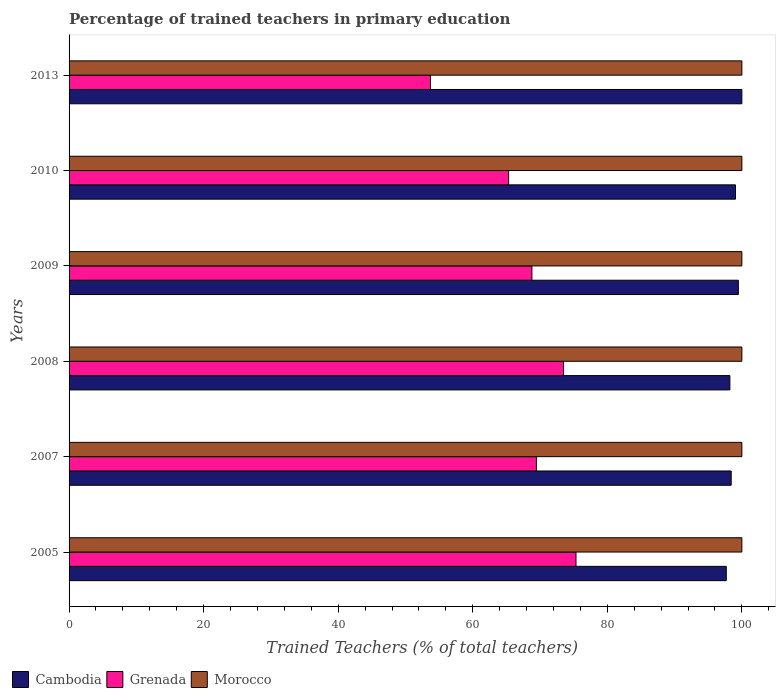Are the number of bars per tick equal to the number of legend labels?
Offer a terse response. Yes. Are the number of bars on each tick of the Y-axis equal?
Your response must be concise. Yes. How many bars are there on the 1st tick from the top?
Provide a succinct answer. 3. How many bars are there on the 4th tick from the bottom?
Your answer should be compact. 3. Across all years, what is the maximum percentage of trained teachers in Grenada?
Make the answer very short. 75.35. Across all years, what is the minimum percentage of trained teachers in Grenada?
Provide a succinct answer. 53.71. In which year was the percentage of trained teachers in Cambodia minimum?
Your response must be concise. 2005. What is the total percentage of trained teachers in Morocco in the graph?
Your answer should be compact. 600. What is the difference between the percentage of trained teachers in Grenada in 2005 and the percentage of trained teachers in Cambodia in 2007?
Give a very brief answer. -23.07. What is the average percentage of trained teachers in Cambodia per year?
Your answer should be compact. 98.81. In how many years, is the percentage of trained teachers in Morocco greater than 72 %?
Provide a short and direct response. 6. What is the ratio of the percentage of trained teachers in Grenada in 2007 to that in 2009?
Your answer should be very brief. 1.01. What is the difference between the highest and the second highest percentage of trained teachers in Grenada?
Ensure brevity in your answer.  1.85. What does the 1st bar from the top in 2008 represents?
Provide a succinct answer. Morocco. What does the 2nd bar from the bottom in 2005 represents?
Make the answer very short. Grenada. What is the difference between two consecutive major ticks on the X-axis?
Ensure brevity in your answer.  20. Does the graph contain any zero values?
Offer a terse response. No. Does the graph contain grids?
Your response must be concise. No. How are the legend labels stacked?
Your answer should be very brief. Horizontal. What is the title of the graph?
Your answer should be very brief. Percentage of trained teachers in primary education. Does "Hong Kong" appear as one of the legend labels in the graph?
Provide a succinct answer. No. What is the label or title of the X-axis?
Give a very brief answer. Trained Teachers (% of total teachers). What is the Trained Teachers (% of total teachers) of Cambodia in 2005?
Provide a short and direct response. 97.69. What is the Trained Teachers (% of total teachers) in Grenada in 2005?
Your answer should be compact. 75.35. What is the Trained Teachers (% of total teachers) in Cambodia in 2007?
Ensure brevity in your answer.  98.41. What is the Trained Teachers (% of total teachers) in Grenada in 2007?
Give a very brief answer. 69.46. What is the Trained Teachers (% of total teachers) of Cambodia in 2008?
Ensure brevity in your answer.  98.22. What is the Trained Teachers (% of total teachers) in Grenada in 2008?
Keep it short and to the point. 73.5. What is the Trained Teachers (% of total teachers) in Morocco in 2008?
Your answer should be compact. 100. What is the Trained Teachers (% of total teachers) in Cambodia in 2009?
Your response must be concise. 99.48. What is the Trained Teachers (% of total teachers) of Grenada in 2009?
Make the answer very short. 68.8. What is the Trained Teachers (% of total teachers) of Cambodia in 2010?
Your answer should be very brief. 99.06. What is the Trained Teachers (% of total teachers) of Grenada in 2010?
Provide a succinct answer. 65.33. What is the Trained Teachers (% of total teachers) in Grenada in 2013?
Give a very brief answer. 53.71. Across all years, what is the maximum Trained Teachers (% of total teachers) in Grenada?
Your response must be concise. 75.35. Across all years, what is the minimum Trained Teachers (% of total teachers) of Cambodia?
Give a very brief answer. 97.69. Across all years, what is the minimum Trained Teachers (% of total teachers) of Grenada?
Provide a short and direct response. 53.71. Across all years, what is the minimum Trained Teachers (% of total teachers) in Morocco?
Your answer should be very brief. 100. What is the total Trained Teachers (% of total teachers) of Cambodia in the graph?
Your answer should be compact. 592.85. What is the total Trained Teachers (% of total teachers) of Grenada in the graph?
Offer a terse response. 406.15. What is the total Trained Teachers (% of total teachers) of Morocco in the graph?
Keep it short and to the point. 600. What is the difference between the Trained Teachers (% of total teachers) of Cambodia in 2005 and that in 2007?
Make the answer very short. -0.73. What is the difference between the Trained Teachers (% of total teachers) in Grenada in 2005 and that in 2007?
Provide a succinct answer. 5.89. What is the difference between the Trained Teachers (% of total teachers) in Morocco in 2005 and that in 2007?
Offer a terse response. 0. What is the difference between the Trained Teachers (% of total teachers) in Cambodia in 2005 and that in 2008?
Ensure brevity in your answer.  -0.53. What is the difference between the Trained Teachers (% of total teachers) in Grenada in 2005 and that in 2008?
Your answer should be very brief. 1.85. What is the difference between the Trained Teachers (% of total teachers) of Cambodia in 2005 and that in 2009?
Your answer should be compact. -1.79. What is the difference between the Trained Teachers (% of total teachers) in Grenada in 2005 and that in 2009?
Your answer should be compact. 6.55. What is the difference between the Trained Teachers (% of total teachers) of Cambodia in 2005 and that in 2010?
Offer a terse response. -1.37. What is the difference between the Trained Teachers (% of total teachers) of Grenada in 2005 and that in 2010?
Offer a terse response. 10.01. What is the difference between the Trained Teachers (% of total teachers) in Morocco in 2005 and that in 2010?
Your answer should be compact. 0. What is the difference between the Trained Teachers (% of total teachers) of Cambodia in 2005 and that in 2013?
Offer a very short reply. -2.31. What is the difference between the Trained Teachers (% of total teachers) in Grenada in 2005 and that in 2013?
Offer a very short reply. 21.63. What is the difference between the Trained Teachers (% of total teachers) in Morocco in 2005 and that in 2013?
Offer a very short reply. 0. What is the difference between the Trained Teachers (% of total teachers) in Cambodia in 2007 and that in 2008?
Provide a short and direct response. 0.2. What is the difference between the Trained Teachers (% of total teachers) in Grenada in 2007 and that in 2008?
Your response must be concise. -4.04. What is the difference between the Trained Teachers (% of total teachers) in Cambodia in 2007 and that in 2009?
Give a very brief answer. -1.07. What is the difference between the Trained Teachers (% of total teachers) of Grenada in 2007 and that in 2009?
Ensure brevity in your answer.  0.67. What is the difference between the Trained Teachers (% of total teachers) of Cambodia in 2007 and that in 2010?
Provide a short and direct response. -0.64. What is the difference between the Trained Teachers (% of total teachers) in Grenada in 2007 and that in 2010?
Ensure brevity in your answer.  4.13. What is the difference between the Trained Teachers (% of total teachers) in Morocco in 2007 and that in 2010?
Provide a short and direct response. 0. What is the difference between the Trained Teachers (% of total teachers) of Cambodia in 2007 and that in 2013?
Give a very brief answer. -1.59. What is the difference between the Trained Teachers (% of total teachers) of Grenada in 2007 and that in 2013?
Your answer should be compact. 15.75. What is the difference between the Trained Teachers (% of total teachers) of Cambodia in 2008 and that in 2009?
Make the answer very short. -1.26. What is the difference between the Trained Teachers (% of total teachers) in Grenada in 2008 and that in 2009?
Provide a short and direct response. 4.7. What is the difference between the Trained Teachers (% of total teachers) in Morocco in 2008 and that in 2009?
Offer a very short reply. 0. What is the difference between the Trained Teachers (% of total teachers) of Cambodia in 2008 and that in 2010?
Your answer should be compact. -0.84. What is the difference between the Trained Teachers (% of total teachers) in Grenada in 2008 and that in 2010?
Ensure brevity in your answer.  8.16. What is the difference between the Trained Teachers (% of total teachers) of Morocco in 2008 and that in 2010?
Make the answer very short. 0. What is the difference between the Trained Teachers (% of total teachers) of Cambodia in 2008 and that in 2013?
Your response must be concise. -1.78. What is the difference between the Trained Teachers (% of total teachers) in Grenada in 2008 and that in 2013?
Give a very brief answer. 19.78. What is the difference between the Trained Teachers (% of total teachers) in Cambodia in 2009 and that in 2010?
Your response must be concise. 0.42. What is the difference between the Trained Teachers (% of total teachers) in Grenada in 2009 and that in 2010?
Keep it short and to the point. 3.46. What is the difference between the Trained Teachers (% of total teachers) in Cambodia in 2009 and that in 2013?
Provide a succinct answer. -0.52. What is the difference between the Trained Teachers (% of total teachers) of Grenada in 2009 and that in 2013?
Keep it short and to the point. 15.08. What is the difference between the Trained Teachers (% of total teachers) of Cambodia in 2010 and that in 2013?
Provide a succinct answer. -0.94. What is the difference between the Trained Teachers (% of total teachers) in Grenada in 2010 and that in 2013?
Provide a succinct answer. 11.62. What is the difference between the Trained Teachers (% of total teachers) in Cambodia in 2005 and the Trained Teachers (% of total teachers) in Grenada in 2007?
Offer a very short reply. 28.23. What is the difference between the Trained Teachers (% of total teachers) of Cambodia in 2005 and the Trained Teachers (% of total teachers) of Morocco in 2007?
Make the answer very short. -2.31. What is the difference between the Trained Teachers (% of total teachers) in Grenada in 2005 and the Trained Teachers (% of total teachers) in Morocco in 2007?
Give a very brief answer. -24.65. What is the difference between the Trained Teachers (% of total teachers) in Cambodia in 2005 and the Trained Teachers (% of total teachers) in Grenada in 2008?
Offer a very short reply. 24.19. What is the difference between the Trained Teachers (% of total teachers) in Cambodia in 2005 and the Trained Teachers (% of total teachers) in Morocco in 2008?
Your answer should be compact. -2.31. What is the difference between the Trained Teachers (% of total teachers) of Grenada in 2005 and the Trained Teachers (% of total teachers) of Morocco in 2008?
Make the answer very short. -24.65. What is the difference between the Trained Teachers (% of total teachers) of Cambodia in 2005 and the Trained Teachers (% of total teachers) of Grenada in 2009?
Offer a very short reply. 28.89. What is the difference between the Trained Teachers (% of total teachers) of Cambodia in 2005 and the Trained Teachers (% of total teachers) of Morocco in 2009?
Make the answer very short. -2.31. What is the difference between the Trained Teachers (% of total teachers) of Grenada in 2005 and the Trained Teachers (% of total teachers) of Morocco in 2009?
Offer a terse response. -24.65. What is the difference between the Trained Teachers (% of total teachers) of Cambodia in 2005 and the Trained Teachers (% of total teachers) of Grenada in 2010?
Ensure brevity in your answer.  32.35. What is the difference between the Trained Teachers (% of total teachers) of Cambodia in 2005 and the Trained Teachers (% of total teachers) of Morocco in 2010?
Keep it short and to the point. -2.31. What is the difference between the Trained Teachers (% of total teachers) of Grenada in 2005 and the Trained Teachers (% of total teachers) of Morocco in 2010?
Ensure brevity in your answer.  -24.65. What is the difference between the Trained Teachers (% of total teachers) in Cambodia in 2005 and the Trained Teachers (% of total teachers) in Grenada in 2013?
Your answer should be very brief. 43.97. What is the difference between the Trained Teachers (% of total teachers) of Cambodia in 2005 and the Trained Teachers (% of total teachers) of Morocco in 2013?
Offer a very short reply. -2.31. What is the difference between the Trained Teachers (% of total teachers) of Grenada in 2005 and the Trained Teachers (% of total teachers) of Morocco in 2013?
Give a very brief answer. -24.65. What is the difference between the Trained Teachers (% of total teachers) of Cambodia in 2007 and the Trained Teachers (% of total teachers) of Grenada in 2008?
Provide a succinct answer. 24.92. What is the difference between the Trained Teachers (% of total teachers) of Cambodia in 2007 and the Trained Teachers (% of total teachers) of Morocco in 2008?
Keep it short and to the point. -1.59. What is the difference between the Trained Teachers (% of total teachers) of Grenada in 2007 and the Trained Teachers (% of total teachers) of Morocco in 2008?
Your answer should be very brief. -30.54. What is the difference between the Trained Teachers (% of total teachers) in Cambodia in 2007 and the Trained Teachers (% of total teachers) in Grenada in 2009?
Ensure brevity in your answer.  29.62. What is the difference between the Trained Teachers (% of total teachers) in Cambodia in 2007 and the Trained Teachers (% of total teachers) in Morocco in 2009?
Provide a short and direct response. -1.59. What is the difference between the Trained Teachers (% of total teachers) in Grenada in 2007 and the Trained Teachers (% of total teachers) in Morocco in 2009?
Give a very brief answer. -30.54. What is the difference between the Trained Teachers (% of total teachers) of Cambodia in 2007 and the Trained Teachers (% of total teachers) of Grenada in 2010?
Your answer should be compact. 33.08. What is the difference between the Trained Teachers (% of total teachers) in Cambodia in 2007 and the Trained Teachers (% of total teachers) in Morocco in 2010?
Make the answer very short. -1.59. What is the difference between the Trained Teachers (% of total teachers) of Grenada in 2007 and the Trained Teachers (% of total teachers) of Morocco in 2010?
Your answer should be compact. -30.54. What is the difference between the Trained Teachers (% of total teachers) of Cambodia in 2007 and the Trained Teachers (% of total teachers) of Grenada in 2013?
Provide a succinct answer. 44.7. What is the difference between the Trained Teachers (% of total teachers) in Cambodia in 2007 and the Trained Teachers (% of total teachers) in Morocco in 2013?
Provide a succinct answer. -1.59. What is the difference between the Trained Teachers (% of total teachers) in Grenada in 2007 and the Trained Teachers (% of total teachers) in Morocco in 2013?
Your answer should be compact. -30.54. What is the difference between the Trained Teachers (% of total teachers) in Cambodia in 2008 and the Trained Teachers (% of total teachers) in Grenada in 2009?
Provide a short and direct response. 29.42. What is the difference between the Trained Teachers (% of total teachers) in Cambodia in 2008 and the Trained Teachers (% of total teachers) in Morocco in 2009?
Your answer should be very brief. -1.78. What is the difference between the Trained Teachers (% of total teachers) of Grenada in 2008 and the Trained Teachers (% of total teachers) of Morocco in 2009?
Your response must be concise. -26.5. What is the difference between the Trained Teachers (% of total teachers) in Cambodia in 2008 and the Trained Teachers (% of total teachers) in Grenada in 2010?
Ensure brevity in your answer.  32.88. What is the difference between the Trained Teachers (% of total teachers) of Cambodia in 2008 and the Trained Teachers (% of total teachers) of Morocco in 2010?
Your answer should be compact. -1.78. What is the difference between the Trained Teachers (% of total teachers) of Grenada in 2008 and the Trained Teachers (% of total teachers) of Morocco in 2010?
Your answer should be very brief. -26.5. What is the difference between the Trained Teachers (% of total teachers) in Cambodia in 2008 and the Trained Teachers (% of total teachers) in Grenada in 2013?
Give a very brief answer. 44.5. What is the difference between the Trained Teachers (% of total teachers) in Cambodia in 2008 and the Trained Teachers (% of total teachers) in Morocco in 2013?
Provide a short and direct response. -1.78. What is the difference between the Trained Teachers (% of total teachers) in Grenada in 2008 and the Trained Teachers (% of total teachers) in Morocco in 2013?
Ensure brevity in your answer.  -26.5. What is the difference between the Trained Teachers (% of total teachers) in Cambodia in 2009 and the Trained Teachers (% of total teachers) in Grenada in 2010?
Ensure brevity in your answer.  34.14. What is the difference between the Trained Teachers (% of total teachers) of Cambodia in 2009 and the Trained Teachers (% of total teachers) of Morocco in 2010?
Give a very brief answer. -0.52. What is the difference between the Trained Teachers (% of total teachers) in Grenada in 2009 and the Trained Teachers (% of total teachers) in Morocco in 2010?
Ensure brevity in your answer.  -31.2. What is the difference between the Trained Teachers (% of total teachers) in Cambodia in 2009 and the Trained Teachers (% of total teachers) in Grenada in 2013?
Ensure brevity in your answer.  45.76. What is the difference between the Trained Teachers (% of total teachers) in Cambodia in 2009 and the Trained Teachers (% of total teachers) in Morocco in 2013?
Your answer should be compact. -0.52. What is the difference between the Trained Teachers (% of total teachers) of Grenada in 2009 and the Trained Teachers (% of total teachers) of Morocco in 2013?
Your answer should be very brief. -31.2. What is the difference between the Trained Teachers (% of total teachers) of Cambodia in 2010 and the Trained Teachers (% of total teachers) of Grenada in 2013?
Provide a succinct answer. 45.34. What is the difference between the Trained Teachers (% of total teachers) in Cambodia in 2010 and the Trained Teachers (% of total teachers) in Morocco in 2013?
Give a very brief answer. -0.94. What is the difference between the Trained Teachers (% of total teachers) in Grenada in 2010 and the Trained Teachers (% of total teachers) in Morocco in 2013?
Your response must be concise. -34.67. What is the average Trained Teachers (% of total teachers) in Cambodia per year?
Make the answer very short. 98.81. What is the average Trained Teachers (% of total teachers) of Grenada per year?
Offer a terse response. 67.69. What is the average Trained Teachers (% of total teachers) in Morocco per year?
Provide a short and direct response. 100. In the year 2005, what is the difference between the Trained Teachers (% of total teachers) in Cambodia and Trained Teachers (% of total teachers) in Grenada?
Your response must be concise. 22.34. In the year 2005, what is the difference between the Trained Teachers (% of total teachers) in Cambodia and Trained Teachers (% of total teachers) in Morocco?
Ensure brevity in your answer.  -2.31. In the year 2005, what is the difference between the Trained Teachers (% of total teachers) of Grenada and Trained Teachers (% of total teachers) of Morocco?
Offer a very short reply. -24.65. In the year 2007, what is the difference between the Trained Teachers (% of total teachers) of Cambodia and Trained Teachers (% of total teachers) of Grenada?
Your answer should be compact. 28.95. In the year 2007, what is the difference between the Trained Teachers (% of total teachers) of Cambodia and Trained Teachers (% of total teachers) of Morocco?
Ensure brevity in your answer.  -1.59. In the year 2007, what is the difference between the Trained Teachers (% of total teachers) in Grenada and Trained Teachers (% of total teachers) in Morocco?
Your answer should be compact. -30.54. In the year 2008, what is the difference between the Trained Teachers (% of total teachers) of Cambodia and Trained Teachers (% of total teachers) of Grenada?
Ensure brevity in your answer.  24.72. In the year 2008, what is the difference between the Trained Teachers (% of total teachers) of Cambodia and Trained Teachers (% of total teachers) of Morocco?
Offer a very short reply. -1.78. In the year 2008, what is the difference between the Trained Teachers (% of total teachers) of Grenada and Trained Teachers (% of total teachers) of Morocco?
Offer a very short reply. -26.5. In the year 2009, what is the difference between the Trained Teachers (% of total teachers) in Cambodia and Trained Teachers (% of total teachers) in Grenada?
Make the answer very short. 30.68. In the year 2009, what is the difference between the Trained Teachers (% of total teachers) of Cambodia and Trained Teachers (% of total teachers) of Morocco?
Your response must be concise. -0.52. In the year 2009, what is the difference between the Trained Teachers (% of total teachers) of Grenada and Trained Teachers (% of total teachers) of Morocco?
Your answer should be very brief. -31.2. In the year 2010, what is the difference between the Trained Teachers (% of total teachers) of Cambodia and Trained Teachers (% of total teachers) of Grenada?
Ensure brevity in your answer.  33.72. In the year 2010, what is the difference between the Trained Teachers (% of total teachers) of Cambodia and Trained Teachers (% of total teachers) of Morocco?
Your answer should be very brief. -0.94. In the year 2010, what is the difference between the Trained Teachers (% of total teachers) of Grenada and Trained Teachers (% of total teachers) of Morocco?
Make the answer very short. -34.67. In the year 2013, what is the difference between the Trained Teachers (% of total teachers) in Cambodia and Trained Teachers (% of total teachers) in Grenada?
Provide a succinct answer. 46.29. In the year 2013, what is the difference between the Trained Teachers (% of total teachers) in Grenada and Trained Teachers (% of total teachers) in Morocco?
Make the answer very short. -46.29. What is the ratio of the Trained Teachers (% of total teachers) in Cambodia in 2005 to that in 2007?
Make the answer very short. 0.99. What is the ratio of the Trained Teachers (% of total teachers) in Grenada in 2005 to that in 2007?
Provide a short and direct response. 1.08. What is the ratio of the Trained Teachers (% of total teachers) of Morocco in 2005 to that in 2007?
Make the answer very short. 1. What is the ratio of the Trained Teachers (% of total teachers) in Grenada in 2005 to that in 2008?
Keep it short and to the point. 1.03. What is the ratio of the Trained Teachers (% of total teachers) in Cambodia in 2005 to that in 2009?
Your answer should be very brief. 0.98. What is the ratio of the Trained Teachers (% of total teachers) of Grenada in 2005 to that in 2009?
Offer a very short reply. 1.1. What is the ratio of the Trained Teachers (% of total teachers) of Cambodia in 2005 to that in 2010?
Give a very brief answer. 0.99. What is the ratio of the Trained Teachers (% of total teachers) of Grenada in 2005 to that in 2010?
Your response must be concise. 1.15. What is the ratio of the Trained Teachers (% of total teachers) of Cambodia in 2005 to that in 2013?
Make the answer very short. 0.98. What is the ratio of the Trained Teachers (% of total teachers) in Grenada in 2005 to that in 2013?
Your answer should be very brief. 1.4. What is the ratio of the Trained Teachers (% of total teachers) in Morocco in 2005 to that in 2013?
Offer a very short reply. 1. What is the ratio of the Trained Teachers (% of total teachers) of Grenada in 2007 to that in 2008?
Your answer should be compact. 0.95. What is the ratio of the Trained Teachers (% of total teachers) in Morocco in 2007 to that in 2008?
Offer a terse response. 1. What is the ratio of the Trained Teachers (% of total teachers) of Cambodia in 2007 to that in 2009?
Your response must be concise. 0.99. What is the ratio of the Trained Teachers (% of total teachers) of Grenada in 2007 to that in 2009?
Make the answer very short. 1.01. What is the ratio of the Trained Teachers (% of total teachers) of Cambodia in 2007 to that in 2010?
Give a very brief answer. 0.99. What is the ratio of the Trained Teachers (% of total teachers) in Grenada in 2007 to that in 2010?
Keep it short and to the point. 1.06. What is the ratio of the Trained Teachers (% of total teachers) of Cambodia in 2007 to that in 2013?
Provide a short and direct response. 0.98. What is the ratio of the Trained Teachers (% of total teachers) in Grenada in 2007 to that in 2013?
Provide a short and direct response. 1.29. What is the ratio of the Trained Teachers (% of total teachers) in Cambodia in 2008 to that in 2009?
Make the answer very short. 0.99. What is the ratio of the Trained Teachers (% of total teachers) in Grenada in 2008 to that in 2009?
Your answer should be compact. 1.07. What is the ratio of the Trained Teachers (% of total teachers) of Morocco in 2008 to that in 2009?
Provide a short and direct response. 1. What is the ratio of the Trained Teachers (% of total teachers) of Grenada in 2008 to that in 2010?
Offer a very short reply. 1.12. What is the ratio of the Trained Teachers (% of total teachers) of Cambodia in 2008 to that in 2013?
Ensure brevity in your answer.  0.98. What is the ratio of the Trained Teachers (% of total teachers) of Grenada in 2008 to that in 2013?
Provide a succinct answer. 1.37. What is the ratio of the Trained Teachers (% of total teachers) of Morocco in 2008 to that in 2013?
Provide a succinct answer. 1. What is the ratio of the Trained Teachers (% of total teachers) in Cambodia in 2009 to that in 2010?
Give a very brief answer. 1. What is the ratio of the Trained Teachers (% of total teachers) of Grenada in 2009 to that in 2010?
Offer a terse response. 1.05. What is the ratio of the Trained Teachers (% of total teachers) of Morocco in 2009 to that in 2010?
Provide a short and direct response. 1. What is the ratio of the Trained Teachers (% of total teachers) in Grenada in 2009 to that in 2013?
Your answer should be very brief. 1.28. What is the ratio of the Trained Teachers (% of total teachers) in Cambodia in 2010 to that in 2013?
Provide a short and direct response. 0.99. What is the ratio of the Trained Teachers (% of total teachers) of Grenada in 2010 to that in 2013?
Your answer should be compact. 1.22. What is the difference between the highest and the second highest Trained Teachers (% of total teachers) in Cambodia?
Offer a terse response. 0.52. What is the difference between the highest and the second highest Trained Teachers (% of total teachers) in Grenada?
Your answer should be very brief. 1.85. What is the difference between the highest and the second highest Trained Teachers (% of total teachers) of Morocco?
Your response must be concise. 0. What is the difference between the highest and the lowest Trained Teachers (% of total teachers) of Cambodia?
Offer a very short reply. 2.31. What is the difference between the highest and the lowest Trained Teachers (% of total teachers) in Grenada?
Provide a short and direct response. 21.63. What is the difference between the highest and the lowest Trained Teachers (% of total teachers) of Morocco?
Give a very brief answer. 0. 